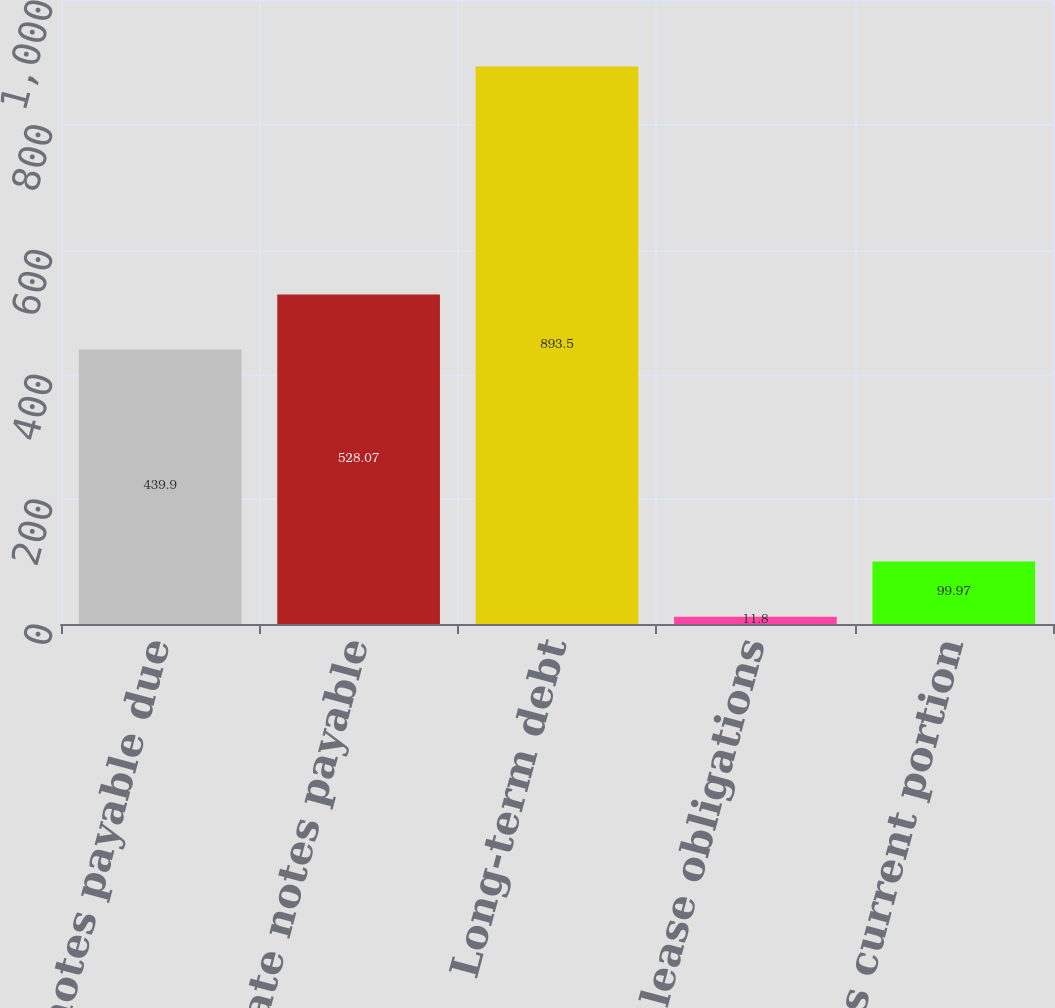<chart> <loc_0><loc_0><loc_500><loc_500><bar_chart><fcel>Fixed rate notes payable due<fcel>Variable rate notes payable<fcel>Long-term debt<fcel>Capital lease obligations<fcel>Less current portion<nl><fcel>439.9<fcel>528.07<fcel>893.5<fcel>11.8<fcel>99.97<nl></chart> 